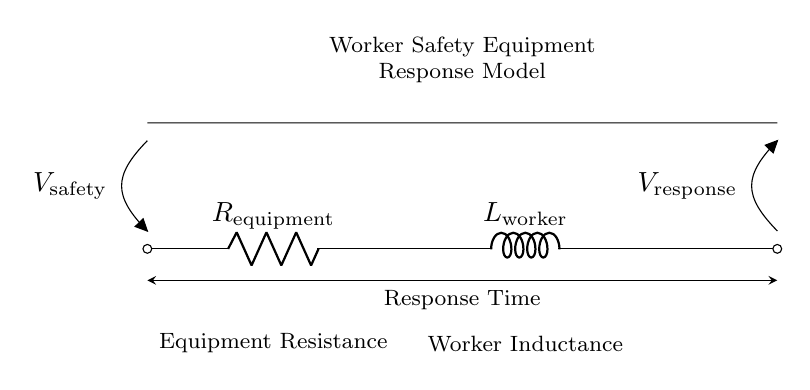What type of components are in this circuit? The circuit consists of a resistor and an inductor, explicitly labeled as R for resistance and L for inductance.
Answer: Resistor and inductor What does R represent in the circuit? R represents the resistance of the worker's safety equipment, which impedes current flow and is critical to the model.
Answer: Equipment resistance What is the voltage source labeled as? The voltage source in the circuit is labeled as V for safety, indicating the voltage applied to the safety equipment.
Answer: V safety What does L stand for in this circuit? L stands for the inductance of the worker, symbolizing the ability to store energy in a magnetic field when current flows through it.
Answer: Worker inductance How does the inductor affect the response time in this circuit? The inductor introduces a delay or lag in current changes due to its property of opposing changes in current flow, thus affecting the overall response time.
Answer: It introduces delay What is the significance of the connections in this circuit? The connections indicate that the resistor and inductor are in series, meaning the total resistance and inductance affect the response time together.
Answer: They are in series How would an increase in R impact the worker safety equipment response? An increase in R would lead to a higher resistance, which would slow down the current, thereby increasing the response time of the equipment.
Answer: It increases response time 